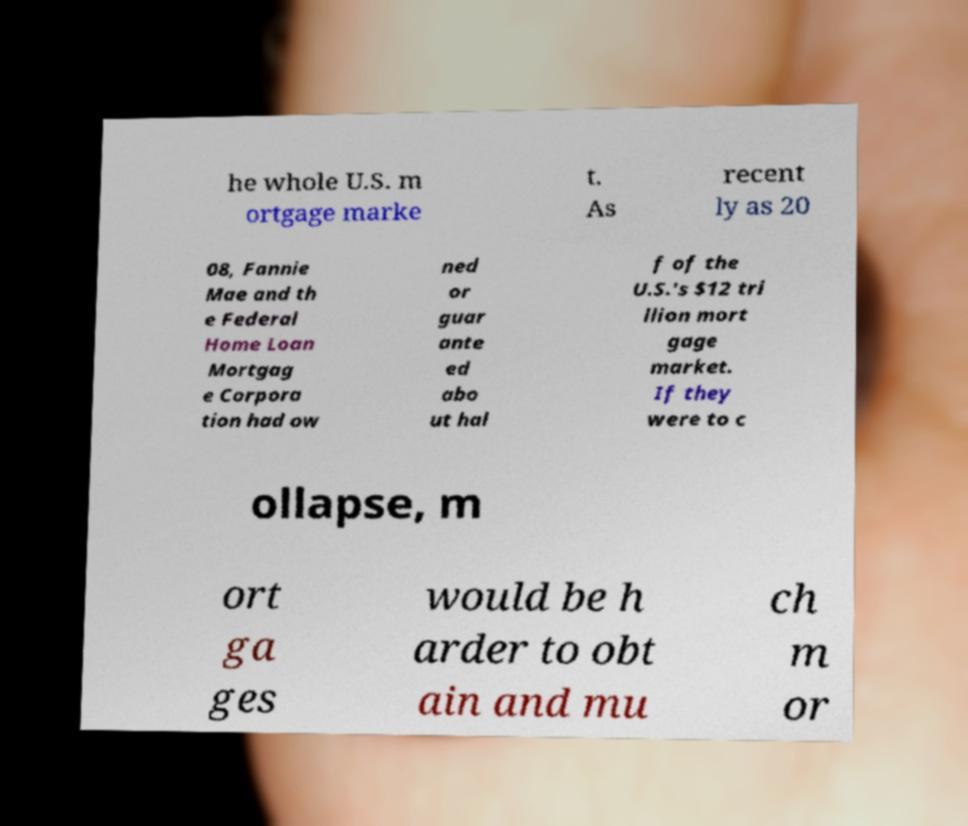Could you extract and type out the text from this image? he whole U.S. m ortgage marke t. As recent ly as 20 08, Fannie Mae and th e Federal Home Loan Mortgag e Corpora tion had ow ned or guar ante ed abo ut hal f of the U.S.'s $12 tri llion mort gage market. If they were to c ollapse, m ort ga ges would be h arder to obt ain and mu ch m or 